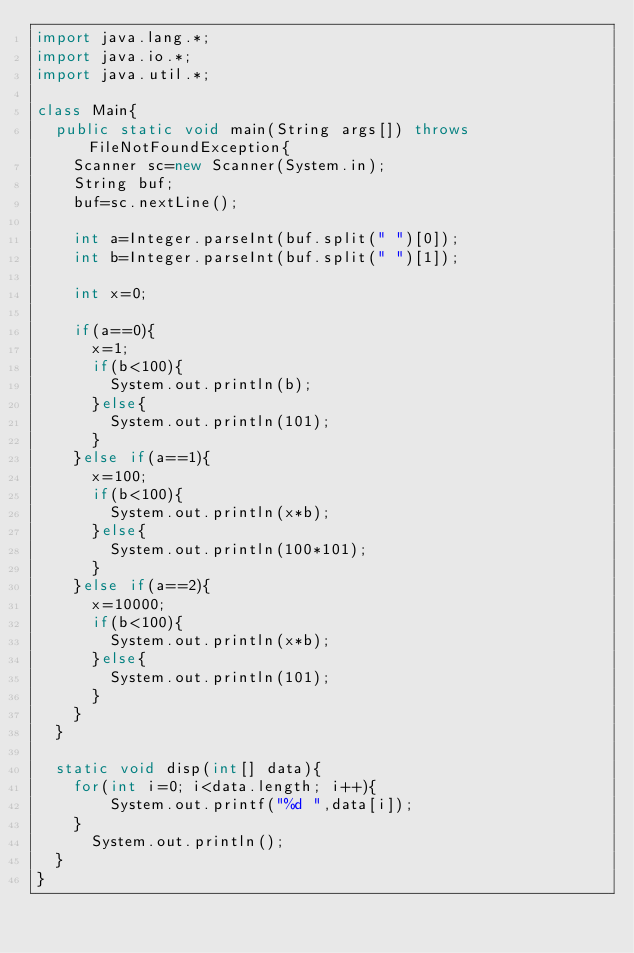<code> <loc_0><loc_0><loc_500><loc_500><_Java_>import java.lang.*;
import java.io.*;
import java.util.*;

class Main{
	public static void main(String args[]) throws FileNotFoundException{
		Scanner sc=new Scanner(System.in);
		String buf;
		buf=sc.nextLine();
		
		int a=Integer.parseInt(buf.split(" ")[0]);
		int b=Integer.parseInt(buf.split(" ")[1]);
		
		int x=0;
		
		if(a==0){
			x=1;
			if(b<100){
				System.out.println(b);
			}else{
				System.out.println(101);
			}
		}else if(a==1){
			x=100;
			if(b<100){
				System.out.println(x*b);
			}else{
				System.out.println(100*101);
			}
		}else if(a==2){
			x=10000;
			if(b<100){
				System.out.println(x*b);
			}else{
				System.out.println(101);
			}
		}
	}

	static void disp(int[] data){
		for(int i=0; i<data.length; i++){
				System.out.printf("%d ",data[i]);
		}
			System.out.println();
	}
}
</code> 